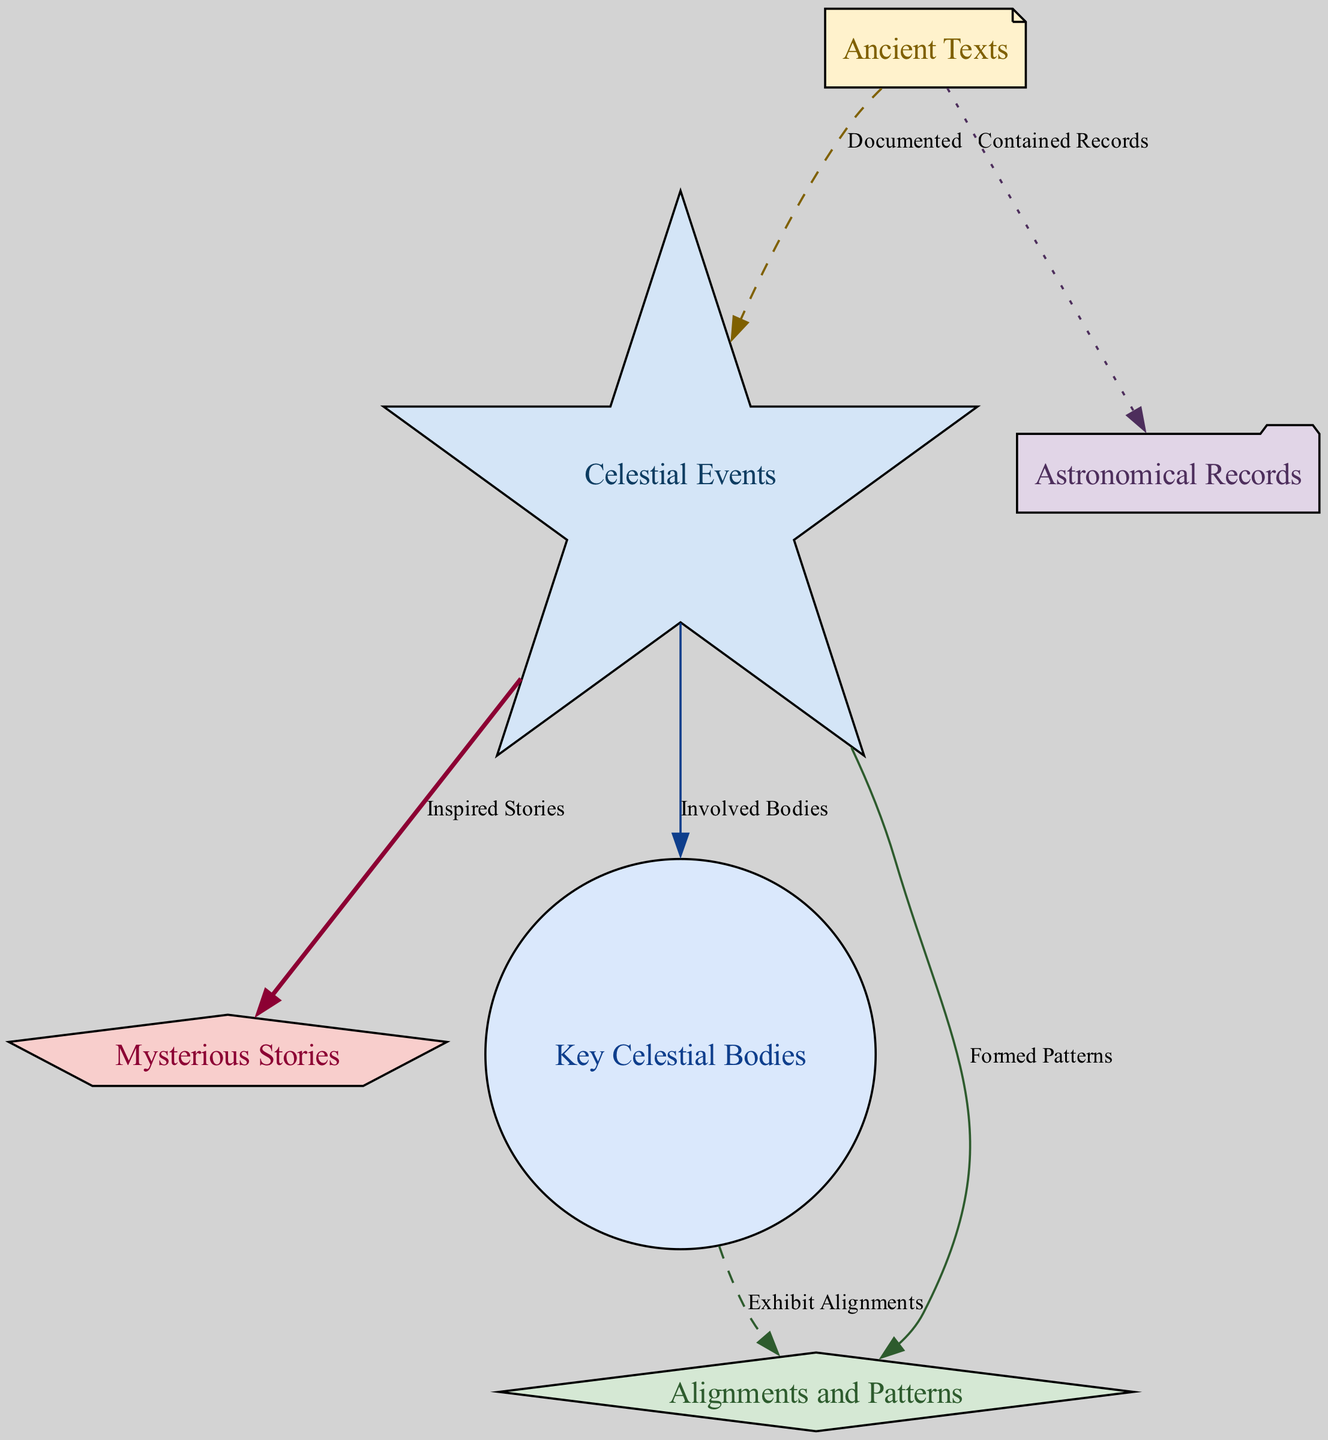What is the total number of nodes in the diagram? The diagram contains six distinct nodes representing different concepts related to ancient texts and celestial events. By counting the entries in the "nodes" section of the data, we find six nodes total.
Answer: 6 Which ancient texts are referenced in the diagram? The node labeled "Ancient Texts" lists sources such as the Dead Sea Scrolls, the Mayan Codices, and the Oracle Bones. This information can be found in the description of that particular node.
Answer: Dead Sea Scrolls, Mayan Codices, Oracle Bones What celestial event types are connected to mysterious stories? The "Celestial Events" node connects directly to "Mysterious Stories" with the labeled edge "Inspired Stories." This indicates that the celestial events inspired the creation of various stories, and this relationship is highlighted in the diagram.
Answer: Inspired Stories How many edges connect the "Key Celestial Bodies" to any other nodes? The "Key Celestial Bodies" node is connected by two edges: one to "Alignments and Patterns" (Exhibit Alignments) and another to "Celestial Events" (Involved Bodies). By looking through the edges that mention the node "Key Celestial Bodies," we count these two connections.
Answer: 2 Which celestial bodies are involved in the celestial events? Referring to the "Celestial Events" node, it states that this category involves bodies such as the Sun, the Moon, planets like Venus and Jupiter, and notable stars. This information can be found in the description of the "Key Celestial Bodies" node as well, which connects to it.
Answer: Sun, Moon, Venus, Jupiter, notable stars What is the relationship between celestial events and alignments and patterns? The edge connecting "Celestial Events" to "Alignments and Patterns" is labeled "Formed Patterns." This indicates that celestial events result in specific alignments and patterns, providing insight into how ancient cultures understood these occurrences.
Answer: Formed Patterns What type of node is "Astronomical Records"? The node labeled "Astronomical Records" has the shape of a folder according to the node styles provided in the visualization code. The diagram's formatting specifies that it is visually represented as such.
Answer: Folder Which edge style indicates the relationship between Ancient Texts and Celestial Events? The edge from "Ancient Texts" to "Celestial Events" is indicated as "Documented," which specifies that the ancient texts document these celestial occurrences. The style of this edge is dashed as described in the edge styles section.
Answer: Dashed How do key celestial bodies exhibit alignments? The "Key Celestial Bodies" node connects to "Alignments and Patterns" through the edge labeled "Exhibit Alignments." This infers that these celestial bodies show specific configurations in their arrangements during celestial events, as per ancient understanding.
Answer: Exhibit Alignments 